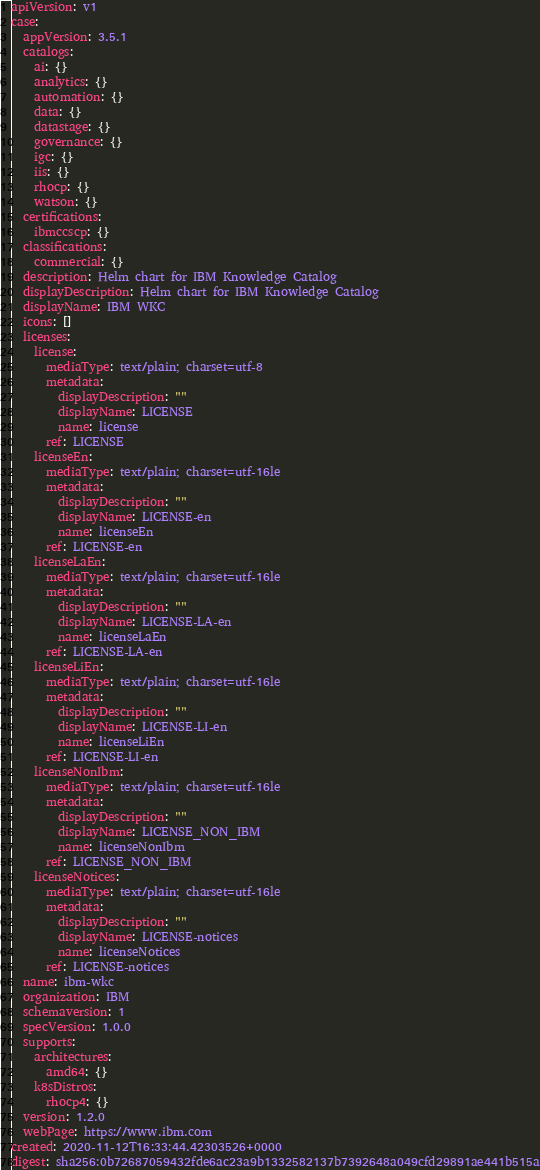<code> <loc_0><loc_0><loc_500><loc_500><_YAML_>apiVersion: v1
case:
  appVersion: 3.5.1
  catalogs:
    ai: {}
    analytics: {}
    automation: {}
    data: {}
    datastage: {}
    governance: {}
    igc: {}
    iis: {}
    rhocp: {}
    watson: {}
  certifications:
    ibmccscp: {}
  classifications:
    commercial: {}
  description: Helm chart for IBM Knowledge Catalog
  displayDescription: Helm chart for IBM Knowledge Catalog
  displayName: IBM WKC
  icons: []
  licenses:
    license:
      mediaType: text/plain; charset=utf-8
      metadata:
        displayDescription: ""
        displayName: LICENSE
        name: license
      ref: LICENSE
    licenseEn:
      mediaType: text/plain; charset=utf-16le
      metadata:
        displayDescription: ""
        displayName: LICENSE-en
        name: licenseEn
      ref: LICENSE-en
    licenseLaEn:
      mediaType: text/plain; charset=utf-16le
      metadata:
        displayDescription: ""
        displayName: LICENSE-LA-en
        name: licenseLaEn
      ref: LICENSE-LA-en
    licenseLiEn:
      mediaType: text/plain; charset=utf-16le
      metadata:
        displayDescription: ""
        displayName: LICENSE-LI-en
        name: licenseLiEn
      ref: LICENSE-LI-en
    licenseNonIbm:
      mediaType: text/plain; charset=utf-16le
      metadata:
        displayDescription: ""
        displayName: LICENSE_NON_IBM
        name: licenseNonIbm
      ref: LICENSE_NON_IBM
    licenseNotices:
      mediaType: text/plain; charset=utf-16le
      metadata:
        displayDescription: ""
        displayName: LICENSE-notices
        name: licenseNotices
      ref: LICENSE-notices
  name: ibm-wkc
  organization: IBM
  schemaversion: 1
  specVersion: 1.0.0
  supports:
    architectures:
      amd64: {}
    k8sDistros:
      rhocp4: {}
  version: 1.2.0
  webPage: https://www.ibm.com
created: 2020-11-12T16:33:44.42303526+0000
digest: sha256:0b72687059432fde6ac23a9b1332582137b7392648a049cfd29891ae441b515a
</code> 